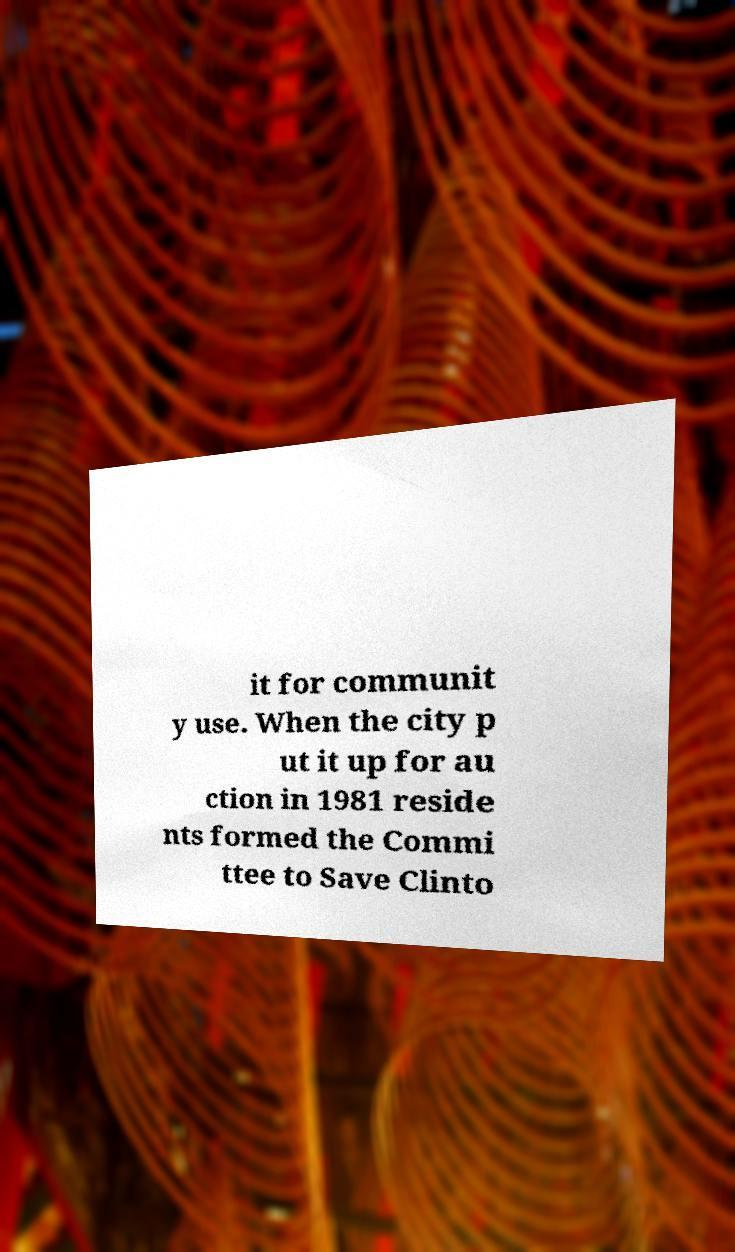Can you accurately transcribe the text from the provided image for me? it for communit y use. When the city p ut it up for au ction in 1981 reside nts formed the Commi ttee to Save Clinto 